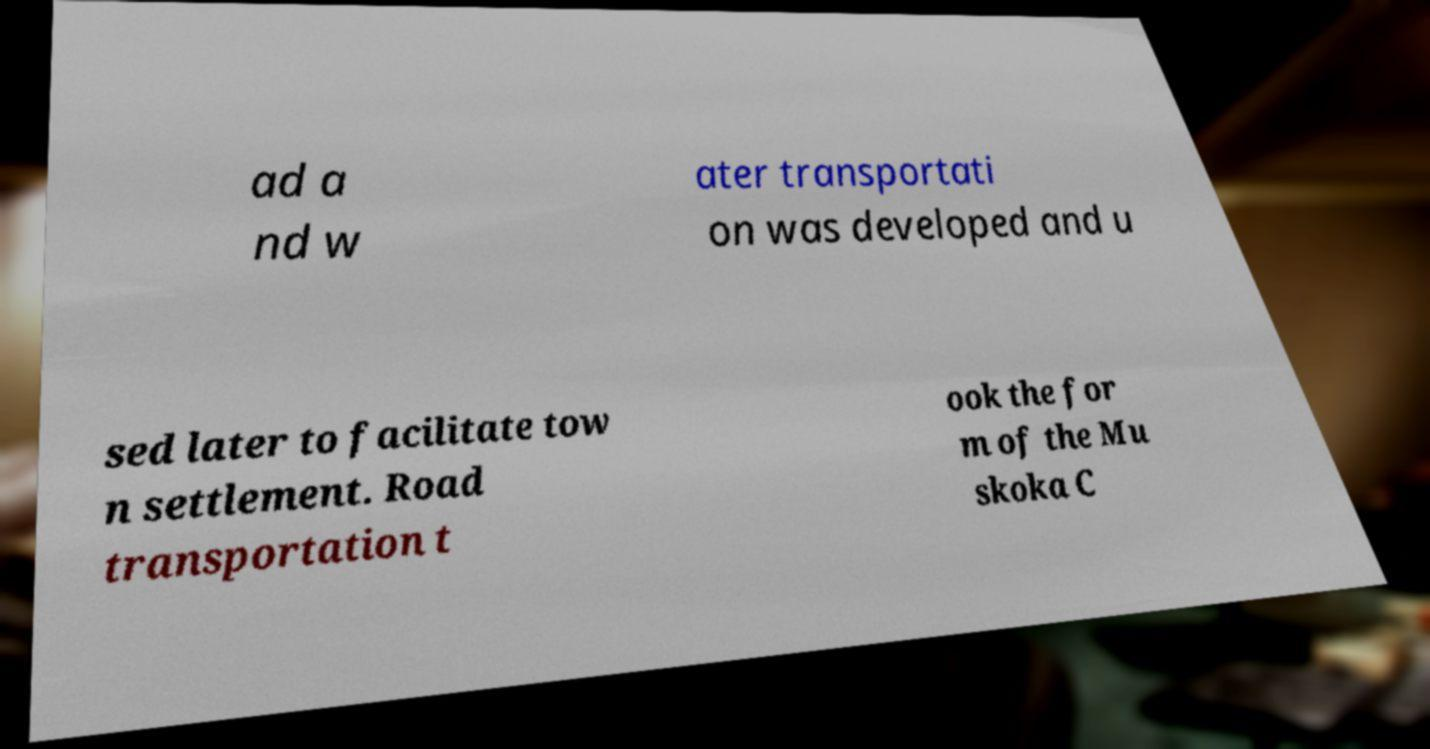Could you assist in decoding the text presented in this image and type it out clearly? ad a nd w ater transportati on was developed and u sed later to facilitate tow n settlement. Road transportation t ook the for m of the Mu skoka C 